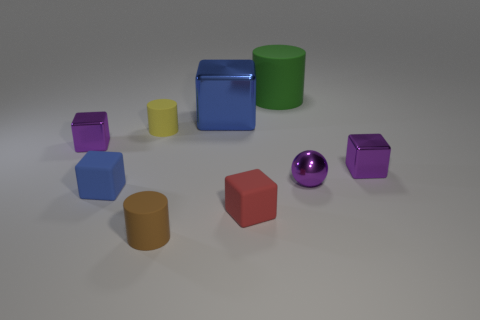What number of red cubes are the same size as the purple shiny ball?
Keep it short and to the point. 1. What is the size of the green cylinder?
Offer a terse response. Large. There is a large blue shiny thing; how many brown rubber objects are in front of it?
Your answer should be compact. 1. What is the shape of the blue object that is made of the same material as the small brown cylinder?
Keep it short and to the point. Cube. Is the number of tiny matte cylinders left of the yellow matte thing less than the number of tiny objects that are left of the purple metallic ball?
Give a very brief answer. Yes. Are there more purple balls than blue blocks?
Make the answer very short. No. What is the purple sphere made of?
Your answer should be compact. Metal. What is the color of the cylinder that is in front of the yellow cylinder?
Provide a succinct answer. Brown. Are there more blue matte objects behind the large green rubber object than blue matte things that are on the right side of the tiny red matte cube?
Keep it short and to the point. No. There is a metal object behind the tiny purple shiny cube that is on the left side of the cylinder to the right of the small red rubber cube; what size is it?
Provide a succinct answer. Large. 